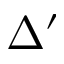Convert formula to latex. <formula><loc_0><loc_0><loc_500><loc_500>\Delta ^ { \prime }</formula> 